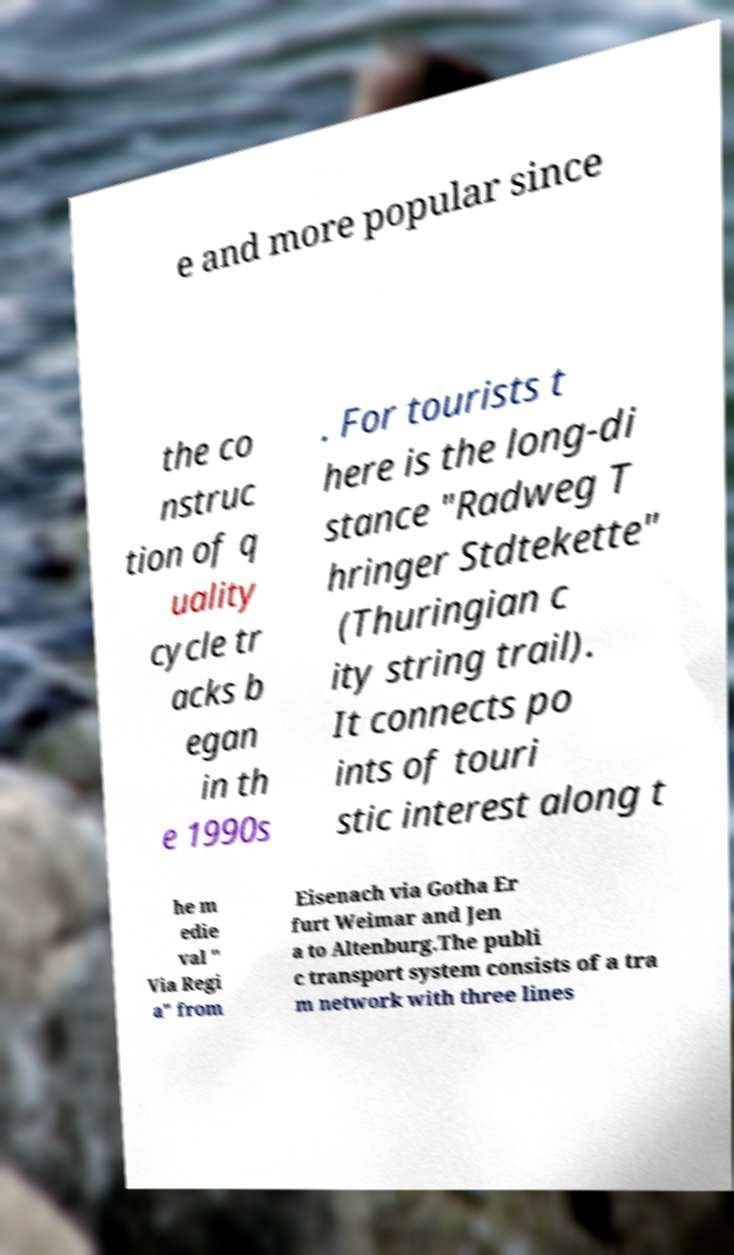There's text embedded in this image that I need extracted. Can you transcribe it verbatim? e and more popular since the co nstruc tion of q uality cycle tr acks b egan in th e 1990s . For tourists t here is the long-di stance "Radweg T hringer Stdtekette" (Thuringian c ity string trail). It connects po ints of touri stic interest along t he m edie val " Via Regi a" from Eisenach via Gotha Er furt Weimar and Jen a to Altenburg.The publi c transport system consists of a tra m network with three lines 